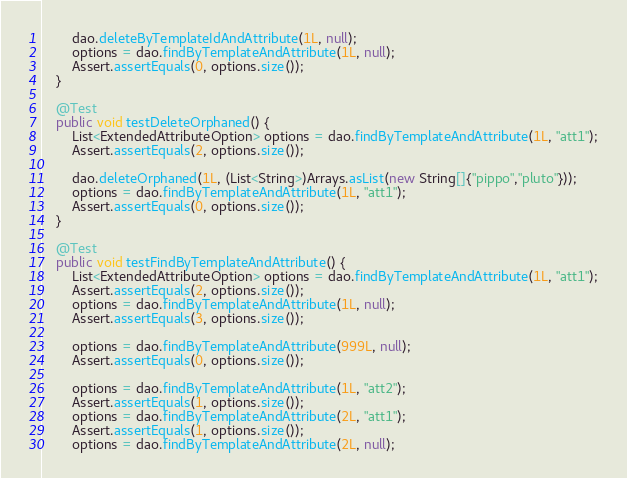<code> <loc_0><loc_0><loc_500><loc_500><_Java_>		dao.deleteByTemplateIdAndAttribute(1L, null);
		options = dao.findByTemplateAndAttribute(1L, null);
		Assert.assertEquals(0, options.size());
	}

	@Test
	public void testDeleteOrphaned() {
		List<ExtendedAttributeOption> options = dao.findByTemplateAndAttribute(1L, "att1");
		Assert.assertEquals(2, options.size());

		dao.deleteOrphaned(1L, (List<String>)Arrays.asList(new String[]{"pippo","pluto"}));
		options = dao.findByTemplateAndAttribute(1L, "att1");
		Assert.assertEquals(0, options.size());
	}
	
	@Test
	public void testFindByTemplateAndAttribute() {
		List<ExtendedAttributeOption> options = dao.findByTemplateAndAttribute(1L, "att1");
		Assert.assertEquals(2, options.size());
		options = dao.findByTemplateAndAttribute(1L, null);
		Assert.assertEquals(3, options.size());

		options = dao.findByTemplateAndAttribute(999L, null);
		Assert.assertEquals(0, options.size());

		options = dao.findByTemplateAndAttribute(1L, "att2");
		Assert.assertEquals(1, options.size());
		options = dao.findByTemplateAndAttribute(2L, "att1");
		Assert.assertEquals(1, options.size());
		options = dao.findByTemplateAndAttribute(2L, null);</code> 